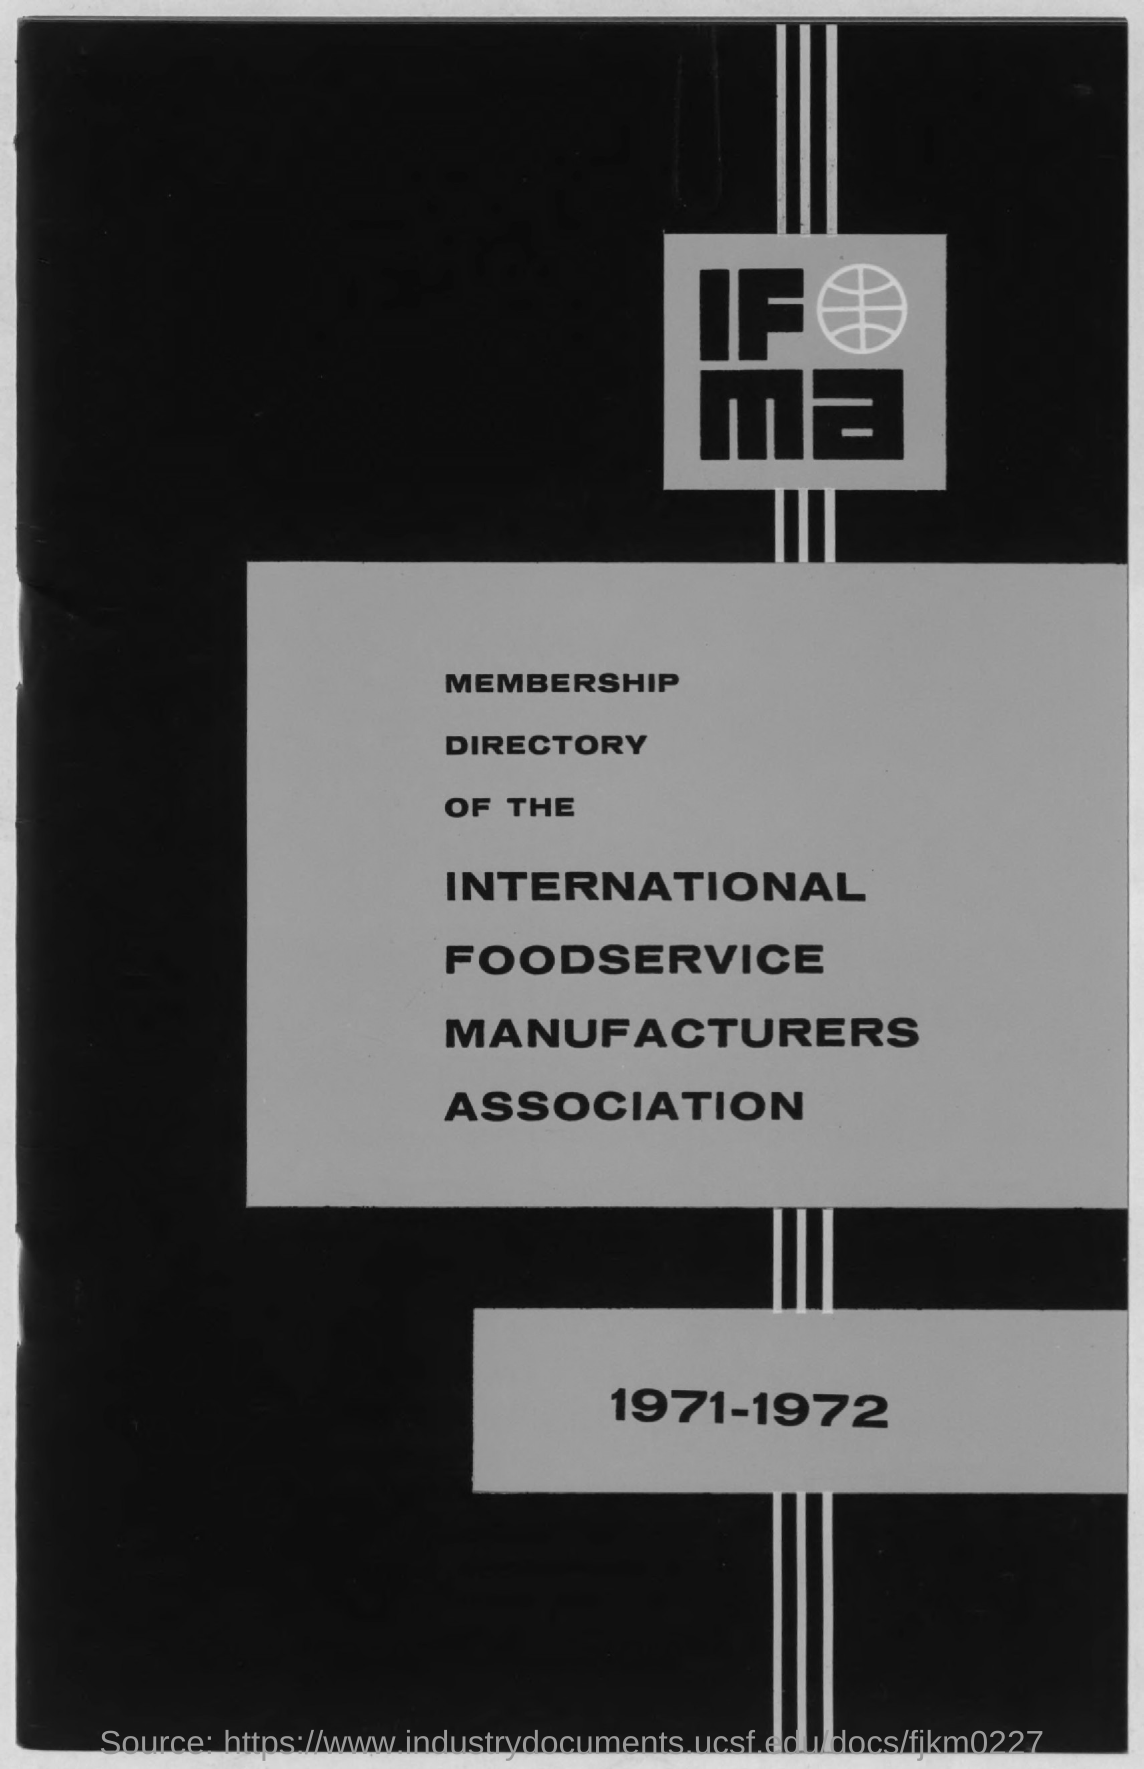Outline some significant characteristics in this image. The speaker asks about the year of a directory. The directory in question is 1971-1972. 